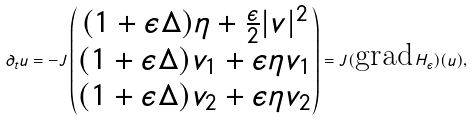<formula> <loc_0><loc_0><loc_500><loc_500>\partial _ { t } u = - J \begin{pmatrix} ( 1 + \epsilon \Delta ) \eta + \frac { \epsilon } 2 | v | ^ { 2 } \\ ( 1 + \epsilon \Delta ) v _ { 1 } + \epsilon \eta v _ { 1 } \\ ( 1 + \epsilon \Delta ) v _ { 2 } + \epsilon \eta v _ { 2 } \end{pmatrix} = J ( \text {grad} \, H _ { \epsilon } ) ( u ) ,</formula> 